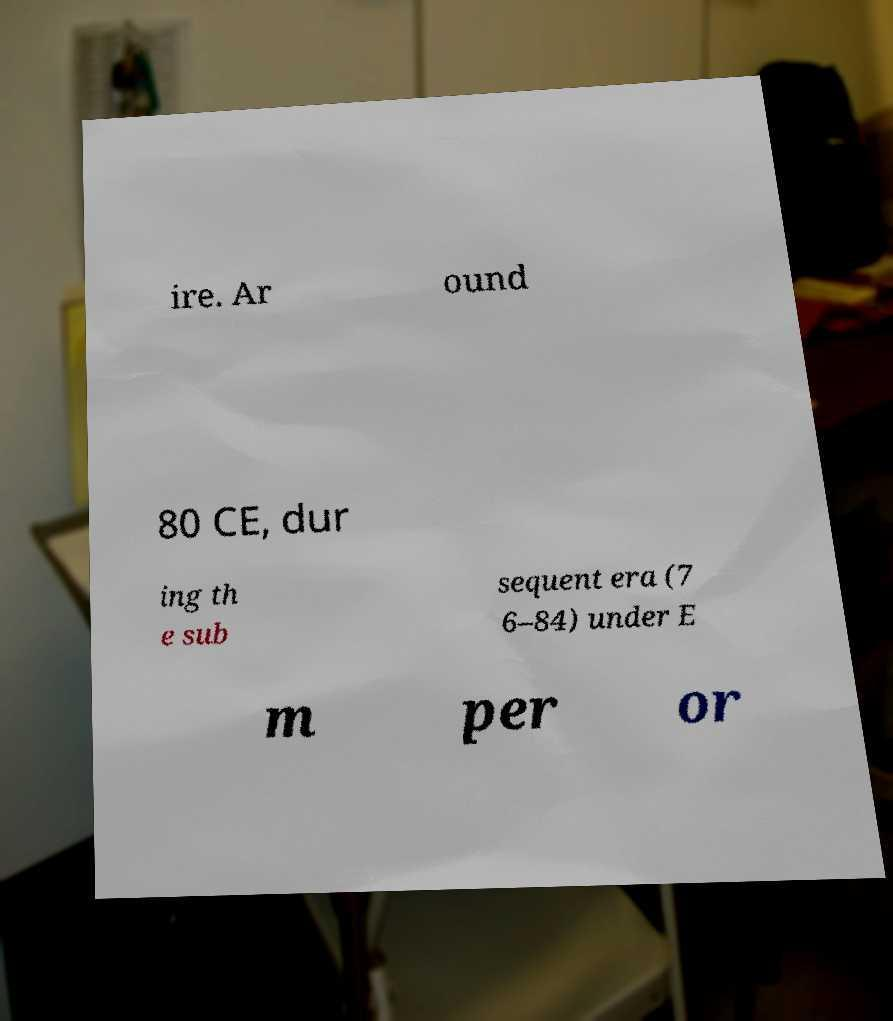For documentation purposes, I need the text within this image transcribed. Could you provide that? ire. Ar ound 80 CE, dur ing th e sub sequent era (7 6–84) under E m per or 